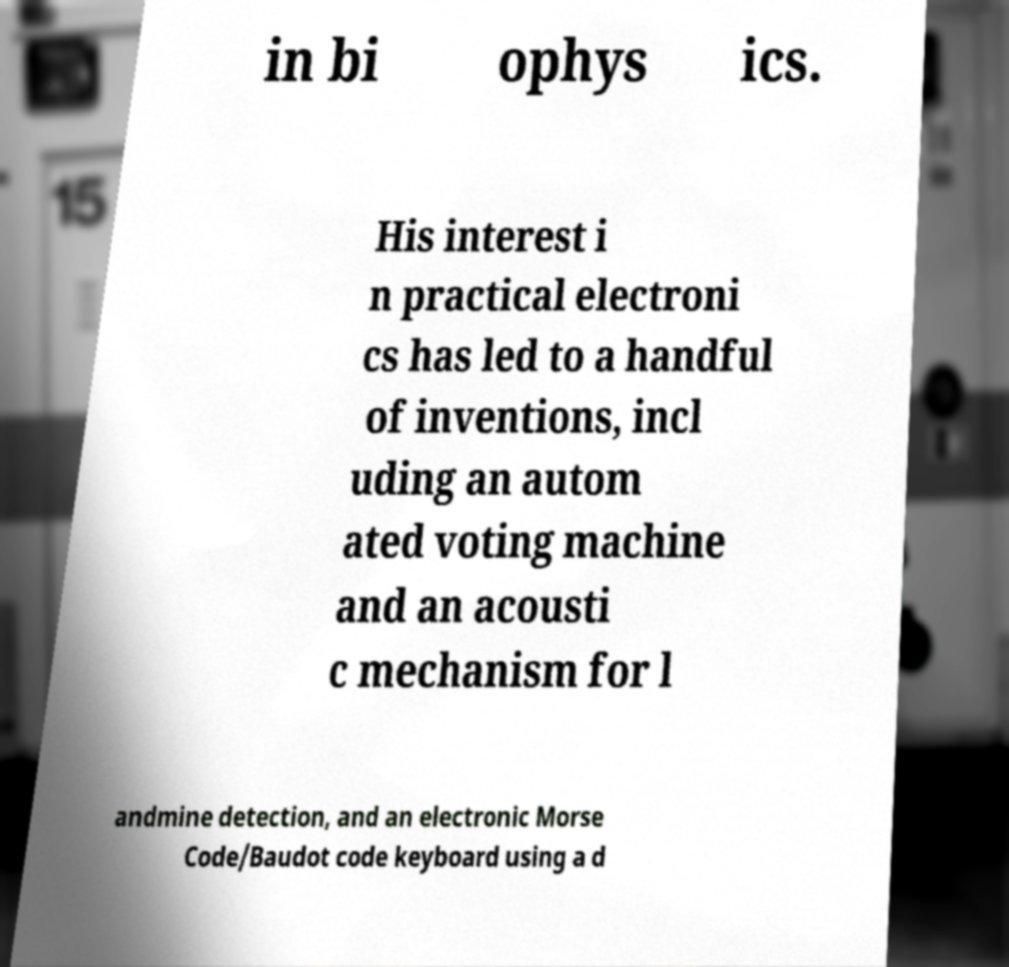Can you read and provide the text displayed in the image?This photo seems to have some interesting text. Can you extract and type it out for me? in bi ophys ics. His interest i n practical electroni cs has led to a handful of inventions, incl uding an autom ated voting machine and an acousti c mechanism for l andmine detection, and an electronic Morse Code/Baudot code keyboard using a d 